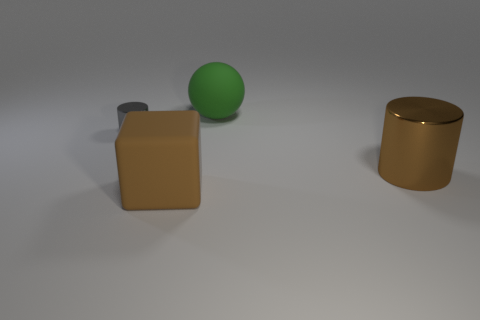Is there anything else that is the same size as the gray cylinder?
Ensure brevity in your answer.  No. There is a cylinder that is the same size as the brown rubber thing; what is its color?
Ensure brevity in your answer.  Brown. Is there a thing of the same color as the cube?
Make the answer very short. Yes. Is the size of the rubber object right of the big cube the same as the gray thing on the left side of the block?
Offer a terse response. No. What is the thing that is both behind the large shiny cylinder and in front of the big rubber ball made of?
Give a very brief answer. Metal. How many other objects are there of the same size as the matte sphere?
Give a very brief answer. 2. There is a cylinder to the left of the rubber sphere; what material is it?
Make the answer very short. Metal. Is the large shiny object the same shape as the brown rubber thing?
Your response must be concise. No. What number of other things are there of the same shape as the small shiny object?
Offer a very short reply. 1. The shiny cylinder that is on the left side of the green thing is what color?
Give a very brief answer. Gray. 